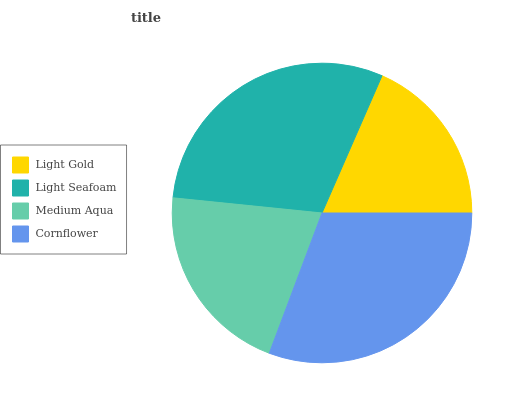Is Light Gold the minimum?
Answer yes or no. Yes. Is Cornflower the maximum?
Answer yes or no. Yes. Is Light Seafoam the minimum?
Answer yes or no. No. Is Light Seafoam the maximum?
Answer yes or no. No. Is Light Seafoam greater than Light Gold?
Answer yes or no. Yes. Is Light Gold less than Light Seafoam?
Answer yes or no. Yes. Is Light Gold greater than Light Seafoam?
Answer yes or no. No. Is Light Seafoam less than Light Gold?
Answer yes or no. No. Is Light Seafoam the high median?
Answer yes or no. Yes. Is Medium Aqua the low median?
Answer yes or no. Yes. Is Cornflower the high median?
Answer yes or no. No. Is Light Seafoam the low median?
Answer yes or no. No. 